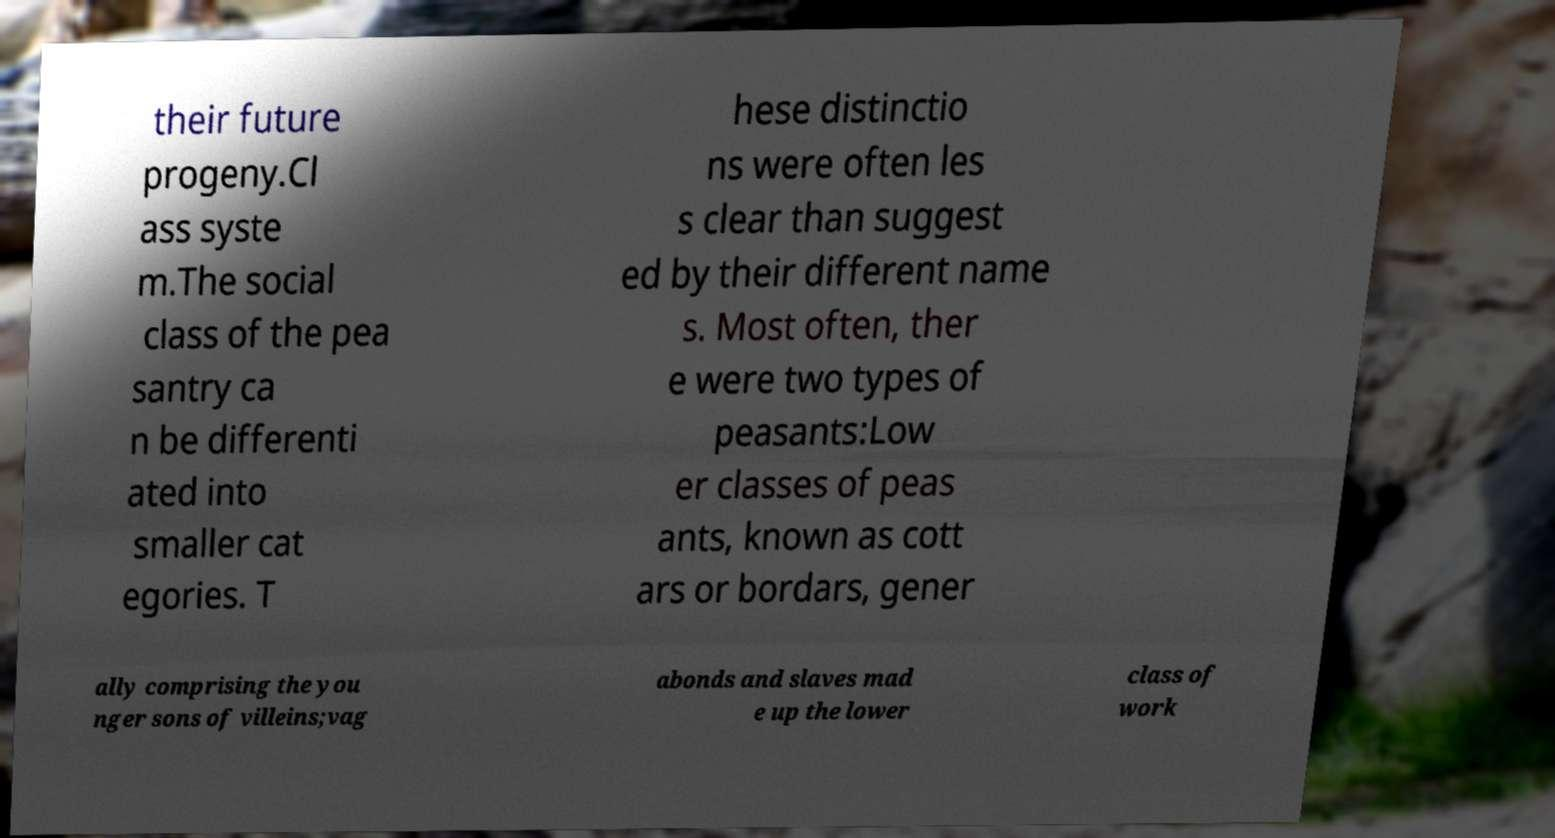I need the written content from this picture converted into text. Can you do that? their future progeny.Cl ass syste m.The social class of the pea santry ca n be differenti ated into smaller cat egories. T hese distinctio ns were often les s clear than suggest ed by their different name s. Most often, ther e were two types of peasants:Low er classes of peas ants, known as cott ars or bordars, gener ally comprising the you nger sons of villeins;vag abonds and slaves mad e up the lower class of work 